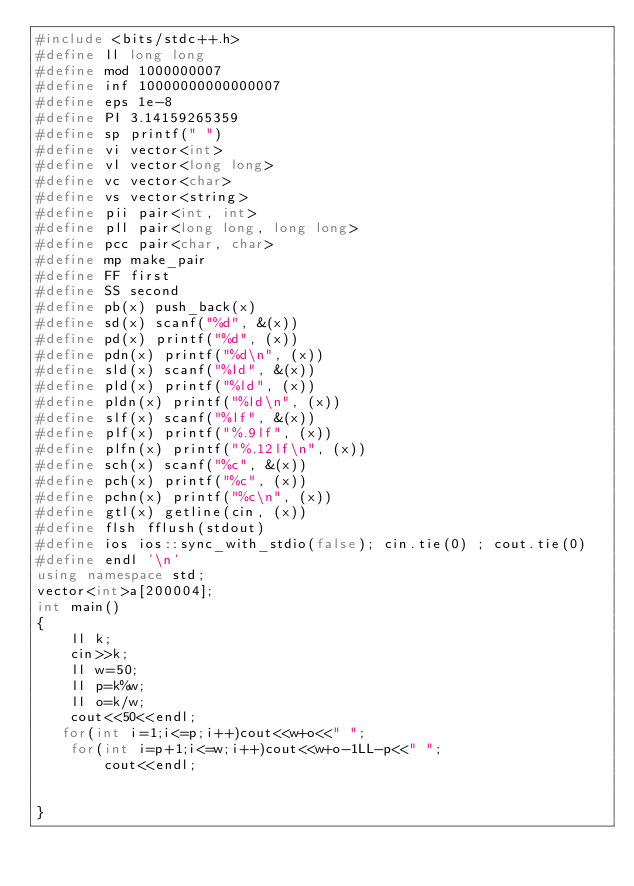<code> <loc_0><loc_0><loc_500><loc_500><_C++_>#include <bits/stdc++.h>
#define ll long long
#define mod 1000000007
#define inf 10000000000000007
#define eps 1e-8
#define PI 3.14159265359
#define sp printf(" ")
#define vi vector<int>
#define vl vector<long long>
#define vc vector<char>
#define vs vector<string>
#define pii pair<int, int>
#define pll pair<long long, long long>
#define pcc pair<char, char>
#define mp make_pair
#define FF first
#define SS second
#define pb(x) push_back(x)
#define sd(x) scanf("%d", &(x))
#define pd(x) printf("%d", (x))
#define pdn(x) printf("%d\n", (x))
#define sld(x) scanf("%ld", &(x))
#define pld(x) printf("%ld", (x))
#define pldn(x) printf("%ld\n", (x))
#define slf(x) scanf("%lf", &(x))
#define plf(x) printf("%.9lf", (x))
#define plfn(x) printf("%.12lf\n", (x))
#define sch(x) scanf("%c", &(x))
#define pch(x) printf("%c", (x))
#define pchn(x) printf("%c\n", (x))
#define gtl(x) getline(cin, (x))
#define flsh fflush(stdout)
#define ios ios::sync_with_stdio(false); cin.tie(0) ; cout.tie(0)
#define endl '\n'
using namespace std;
vector<int>a[200004];
int main()
{
    ll k;
    cin>>k;
    ll w=50;
    ll p=k%w;
    ll o=k/w;
    cout<<50<<endl;
   for(int i=1;i<=p;i++)cout<<w+o<<" ";
    for(int i=p+1;i<=w;i++)cout<<w+o-1LL-p<<" ";
        cout<<endl;

    
}</code> 